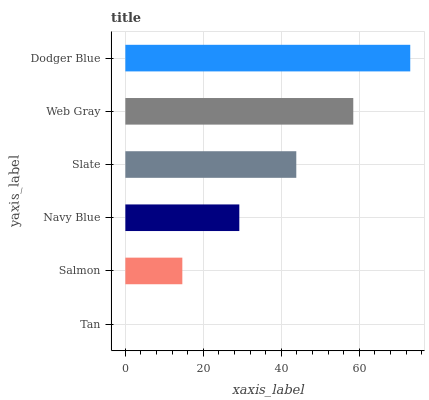Is Tan the minimum?
Answer yes or no. Yes. Is Dodger Blue the maximum?
Answer yes or no. Yes. Is Salmon the minimum?
Answer yes or no. No. Is Salmon the maximum?
Answer yes or no. No. Is Salmon greater than Tan?
Answer yes or no. Yes. Is Tan less than Salmon?
Answer yes or no. Yes. Is Tan greater than Salmon?
Answer yes or no. No. Is Salmon less than Tan?
Answer yes or no. No. Is Slate the high median?
Answer yes or no. Yes. Is Navy Blue the low median?
Answer yes or no. Yes. Is Web Gray the high median?
Answer yes or no. No. Is Tan the low median?
Answer yes or no. No. 